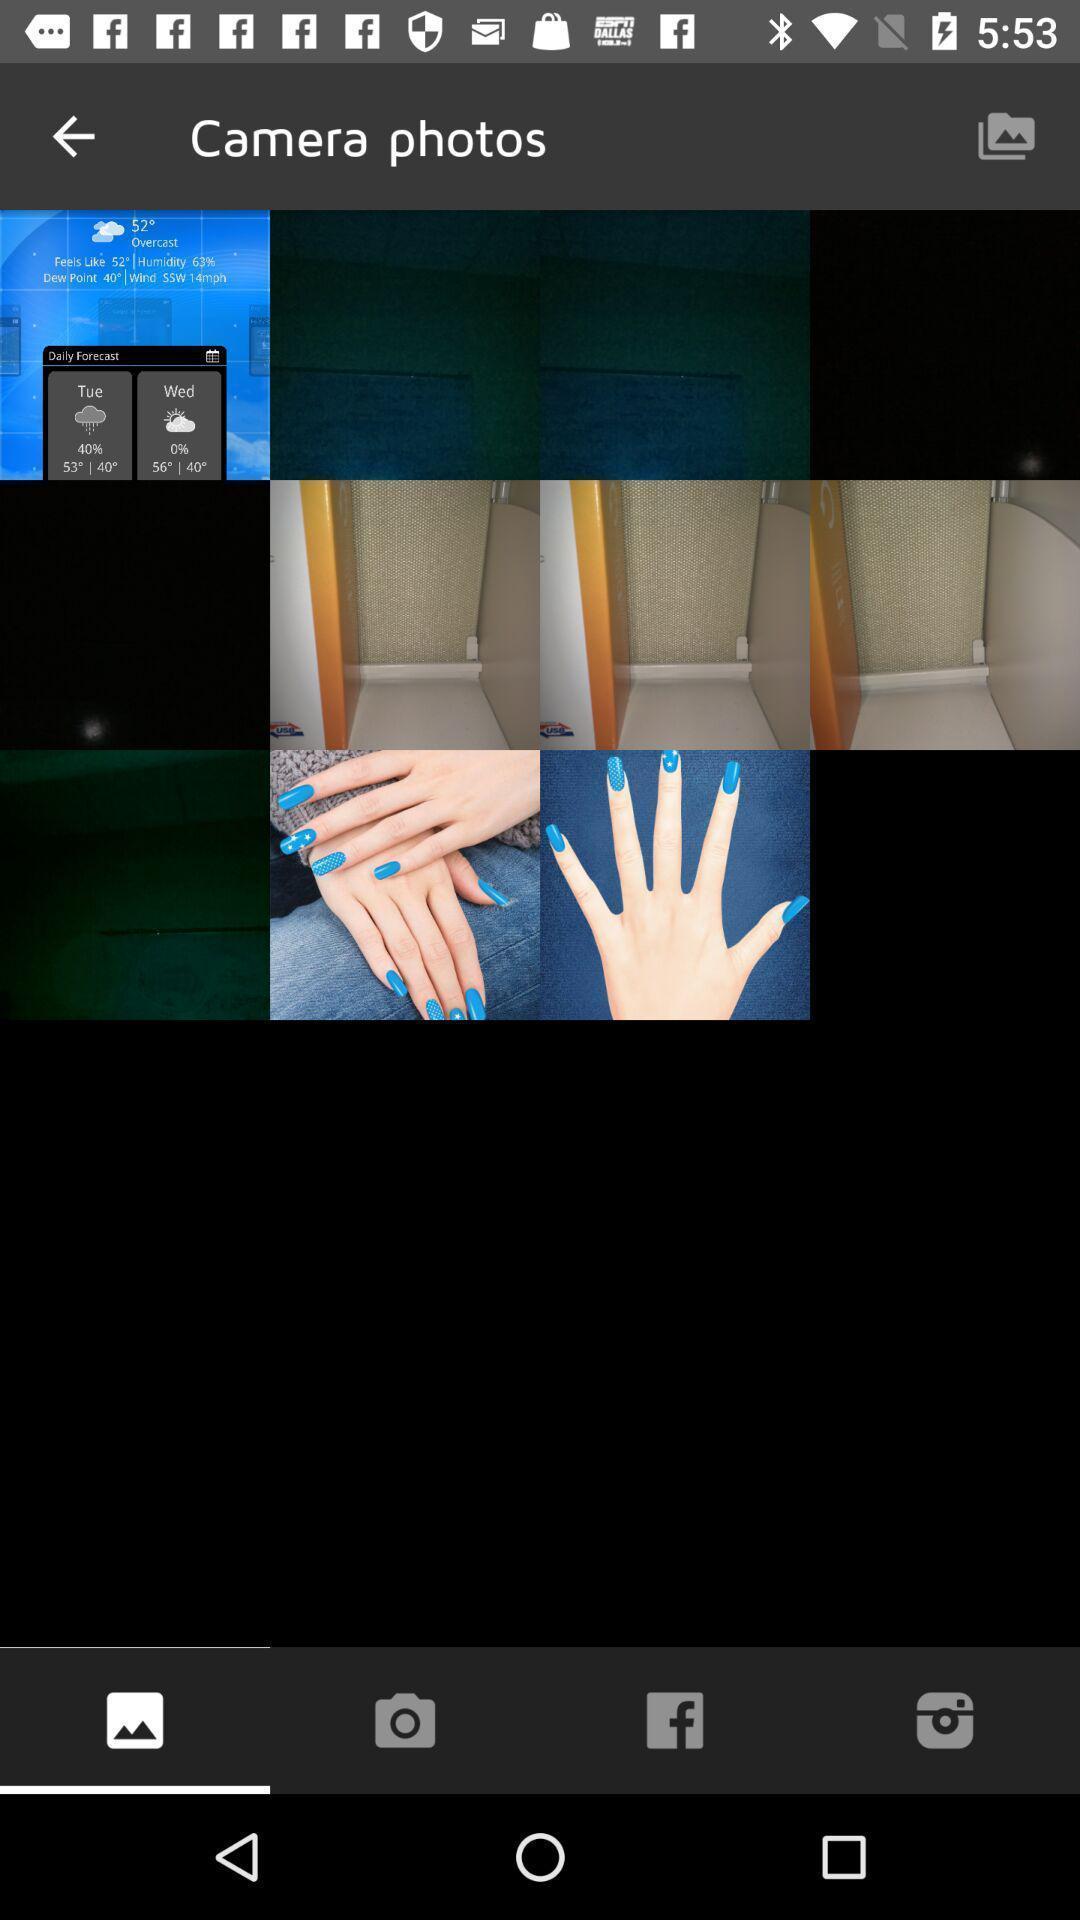Summarize the information in this screenshot. Page shows the hand pictures of camera on dating app. 